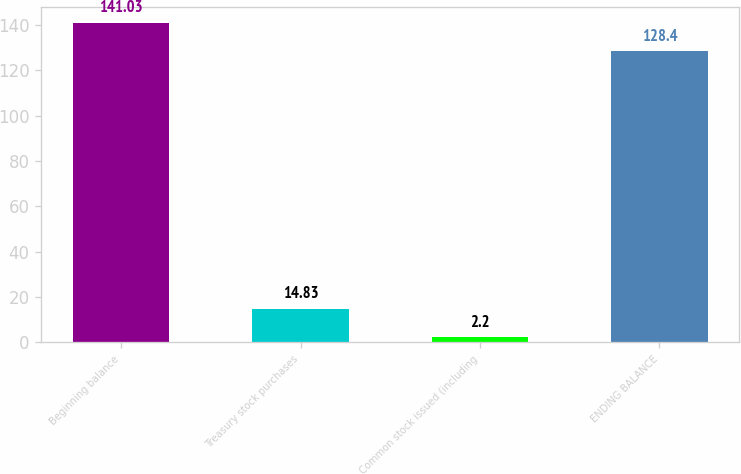<chart> <loc_0><loc_0><loc_500><loc_500><bar_chart><fcel>Beginning balance<fcel>Treasury stock purchases<fcel>Common stock issued (including<fcel>ENDING BALANCE<nl><fcel>141.03<fcel>14.83<fcel>2.2<fcel>128.4<nl></chart> 